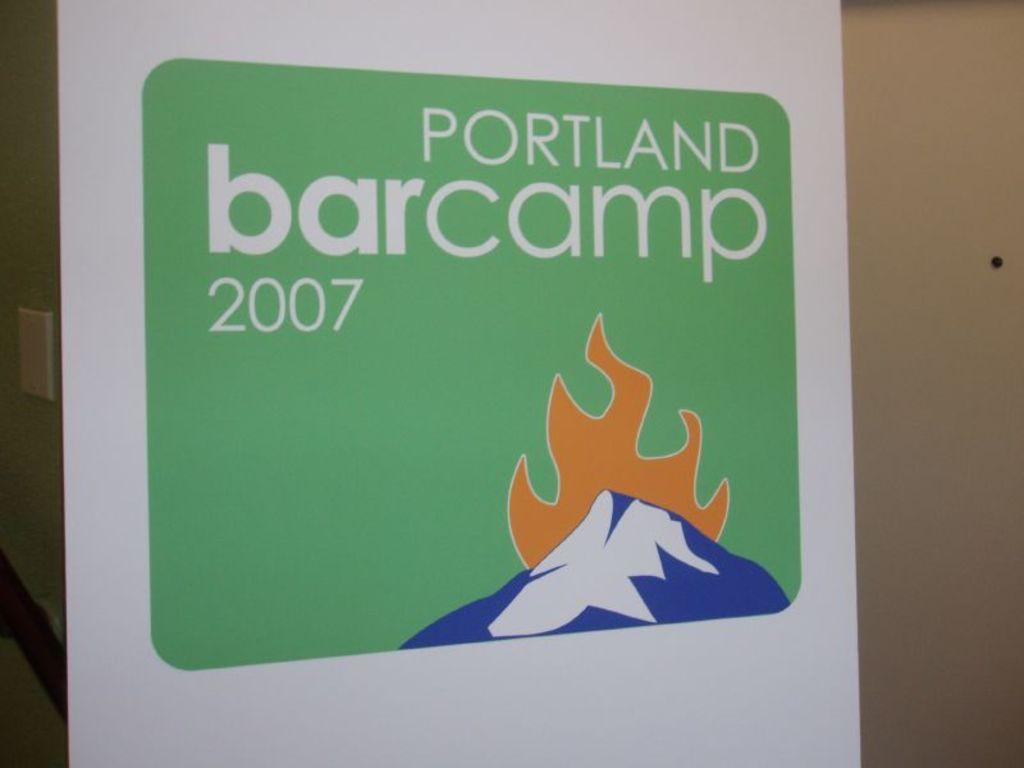<image>
Render a clear and concise summary of the photo. The logo for the 2007 Portland Bar Camp. 